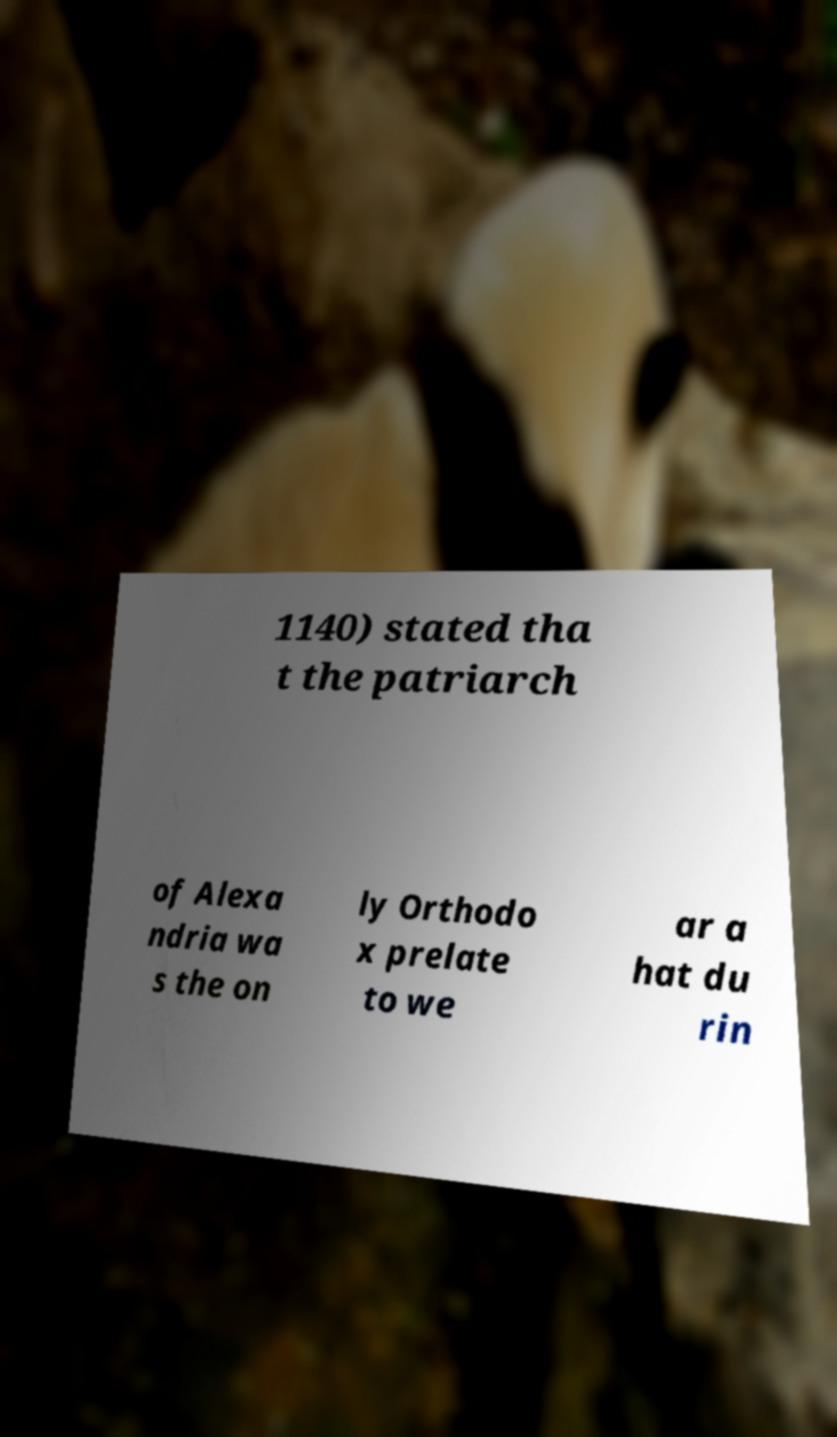What messages or text are displayed in this image? I need them in a readable, typed format. 1140) stated tha t the patriarch of Alexa ndria wa s the on ly Orthodo x prelate to we ar a hat du rin 